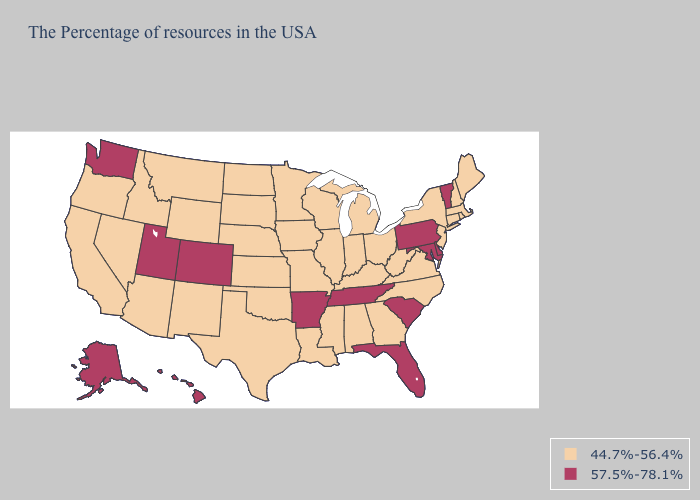Which states have the lowest value in the USA?
Concise answer only. Maine, Massachusetts, Rhode Island, New Hampshire, Connecticut, New York, New Jersey, Virginia, North Carolina, West Virginia, Ohio, Georgia, Michigan, Kentucky, Indiana, Alabama, Wisconsin, Illinois, Mississippi, Louisiana, Missouri, Minnesota, Iowa, Kansas, Nebraska, Oklahoma, Texas, South Dakota, North Dakota, Wyoming, New Mexico, Montana, Arizona, Idaho, Nevada, California, Oregon. What is the highest value in states that border Idaho?
Answer briefly. 57.5%-78.1%. Which states hav the highest value in the MidWest?
Concise answer only. Ohio, Michigan, Indiana, Wisconsin, Illinois, Missouri, Minnesota, Iowa, Kansas, Nebraska, South Dakota, North Dakota. Name the states that have a value in the range 57.5%-78.1%?
Write a very short answer. Vermont, Delaware, Maryland, Pennsylvania, South Carolina, Florida, Tennessee, Arkansas, Colorado, Utah, Washington, Alaska, Hawaii. Which states have the lowest value in the Northeast?
Answer briefly. Maine, Massachusetts, Rhode Island, New Hampshire, Connecticut, New York, New Jersey. What is the highest value in the South ?
Give a very brief answer. 57.5%-78.1%. Name the states that have a value in the range 57.5%-78.1%?
Write a very short answer. Vermont, Delaware, Maryland, Pennsylvania, South Carolina, Florida, Tennessee, Arkansas, Colorado, Utah, Washington, Alaska, Hawaii. What is the value of Mississippi?
Answer briefly. 44.7%-56.4%. Does Maryland have the lowest value in the USA?
Write a very short answer. No. Does Ohio have the highest value in the USA?
Be succinct. No. Among the states that border Indiana , which have the highest value?
Write a very short answer. Ohio, Michigan, Kentucky, Illinois. What is the lowest value in the West?
Give a very brief answer. 44.7%-56.4%. Does Tennessee have the lowest value in the USA?
Short answer required. No. What is the highest value in the Northeast ?
Concise answer only. 57.5%-78.1%. Is the legend a continuous bar?
Keep it brief. No. 